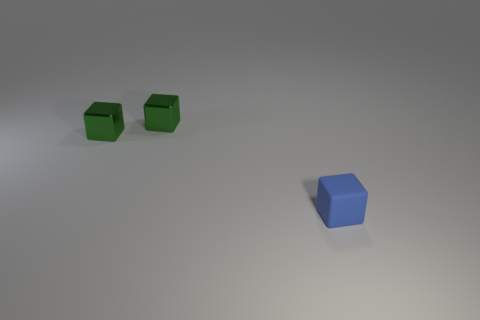Subtract all tiny rubber blocks. How many blocks are left? 2 Subtract all green blocks. How many blocks are left? 1 Add 3 big green matte cylinders. How many objects exist? 6 Subtract all purple cylinders. How many green blocks are left? 2 Subtract 2 blocks. How many blocks are left? 1 Add 2 large gray metal balls. How many large gray metal balls exist? 2 Subtract 0 red cylinders. How many objects are left? 3 Subtract all yellow blocks. Subtract all purple cylinders. How many blocks are left? 3 Subtract all tiny metallic things. Subtract all blue rubber blocks. How many objects are left? 0 Add 3 shiny things. How many shiny things are left? 5 